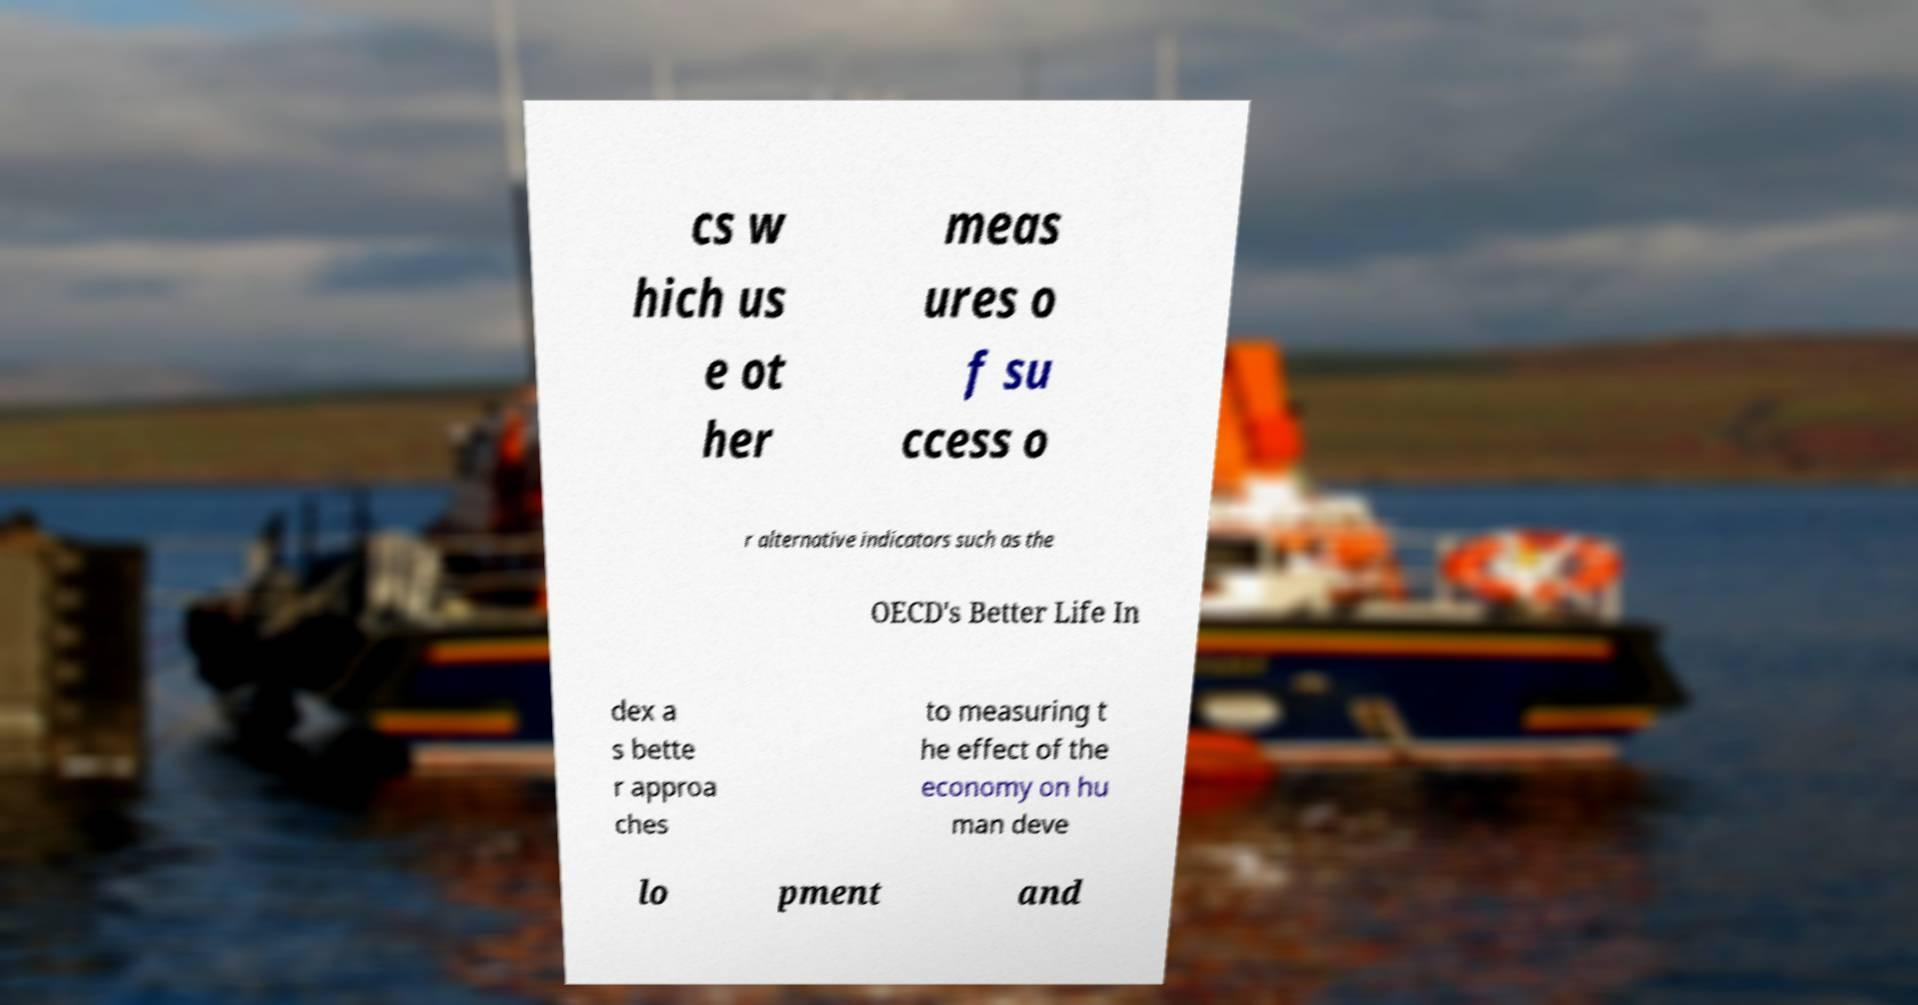Please read and relay the text visible in this image. What does it say? cs w hich us e ot her meas ures o f su ccess o r alternative indicators such as the OECD's Better Life In dex a s bette r approa ches to measuring t he effect of the economy on hu man deve lo pment and 